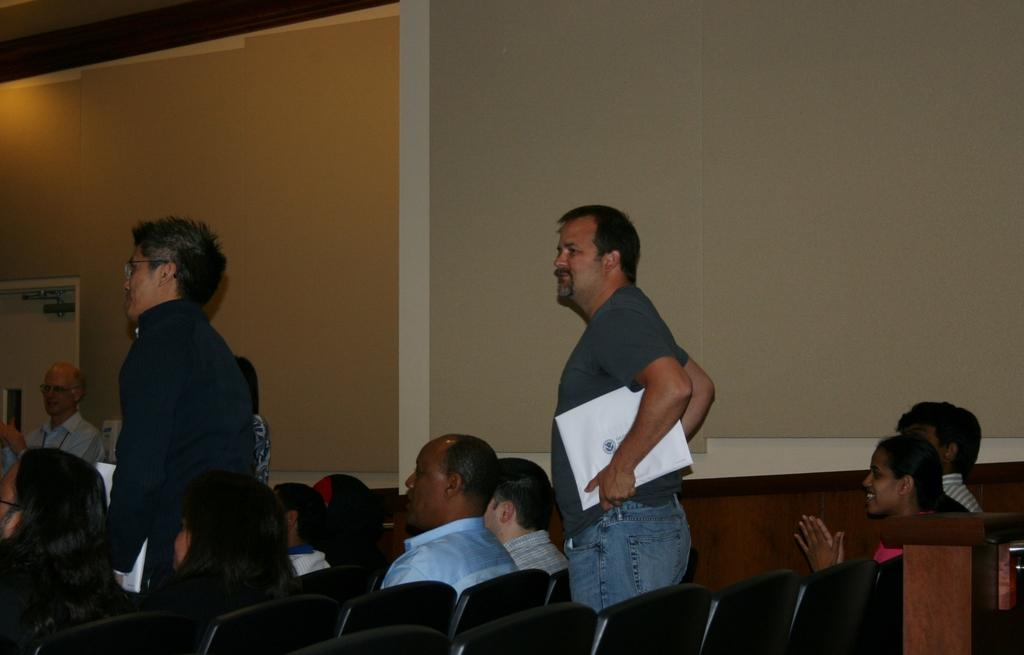What are the people in the image doing? There are people sitting on chairs and standing in the image. Can you describe any objects that the people are holding? One man is holding a file in the image. What can be seen in the background of the image? There is a wall visible in the background of the image. What type of amusement can be seen in the image? There is no amusement present in the image; it features people sitting on chairs and standing, with one man holding a file. How does the son contribute to the scene in the image? There is no mention of a son in the image; it only features people sitting on chairs, standing, and holding a file. 